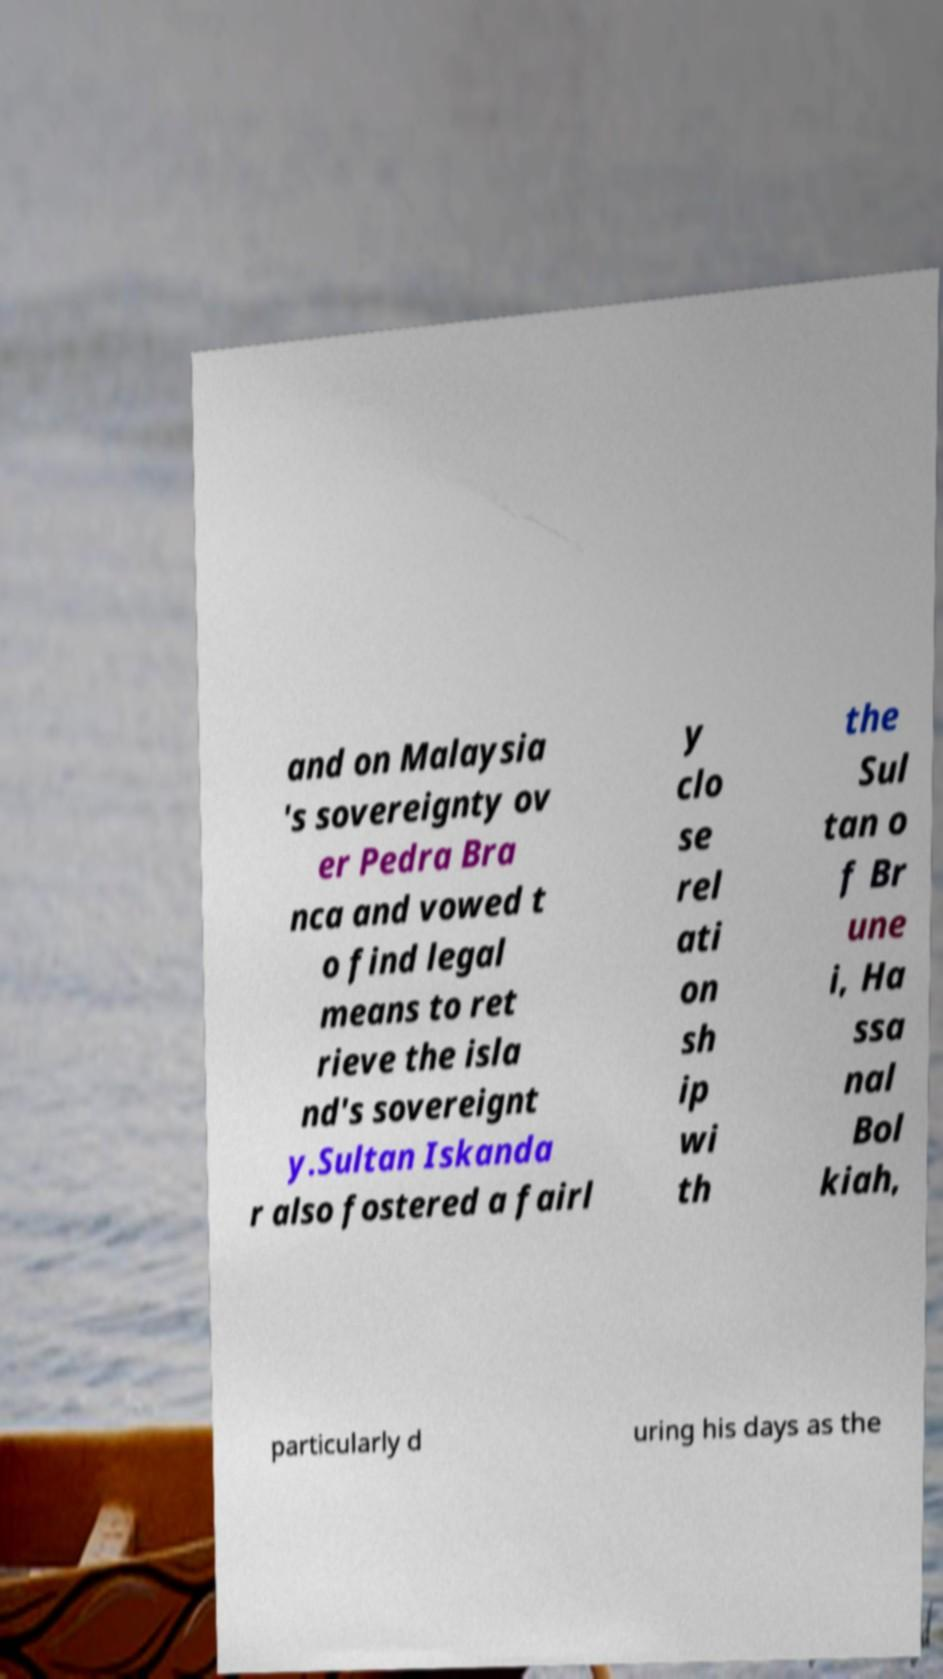Can you accurately transcribe the text from the provided image for me? and on Malaysia 's sovereignty ov er Pedra Bra nca and vowed t o find legal means to ret rieve the isla nd's sovereignt y.Sultan Iskanda r also fostered a fairl y clo se rel ati on sh ip wi th the Sul tan o f Br une i, Ha ssa nal Bol kiah, particularly d uring his days as the 